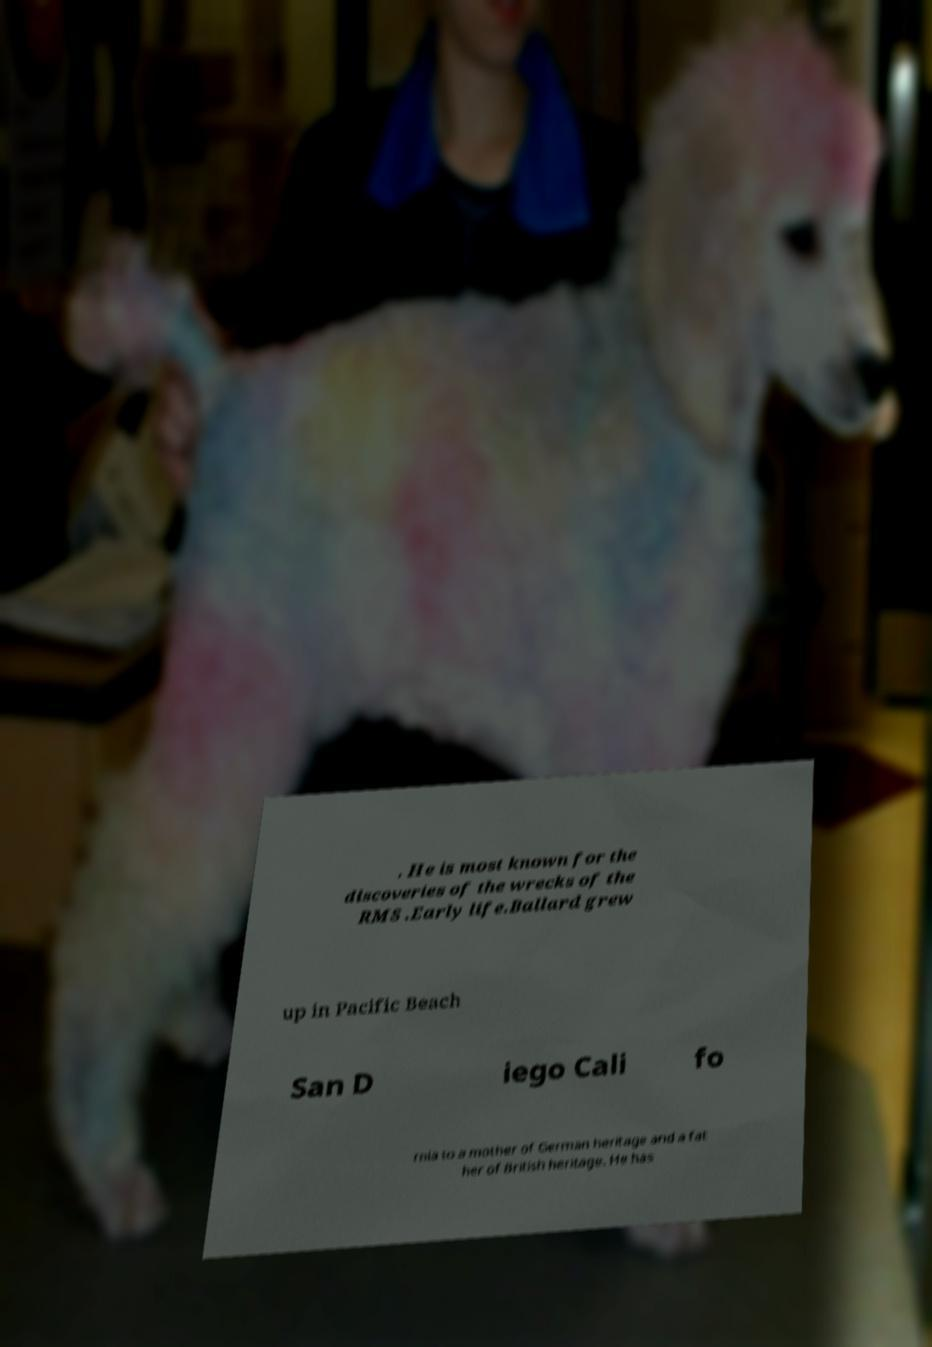There's text embedded in this image that I need extracted. Can you transcribe it verbatim? . He is most known for the discoveries of the wrecks of the RMS .Early life.Ballard grew up in Pacific Beach San D iego Cali fo rnia to a mother of German heritage and a fat her of British heritage. He has 